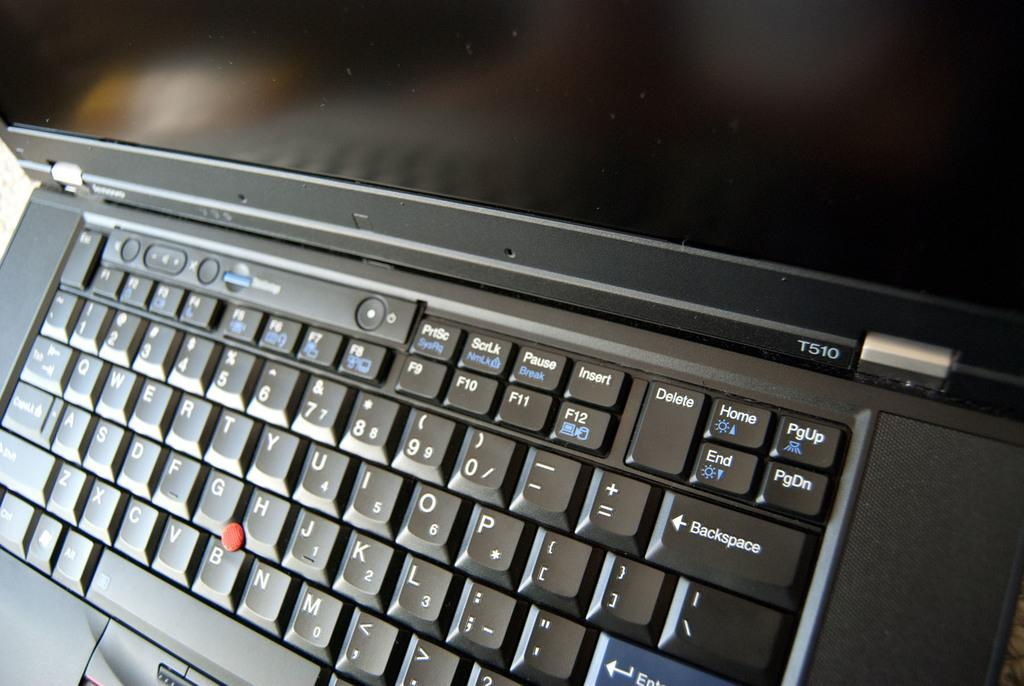<image>
Provide a brief description of the given image. A laptop and keyboard with a PGUP key in the top right 